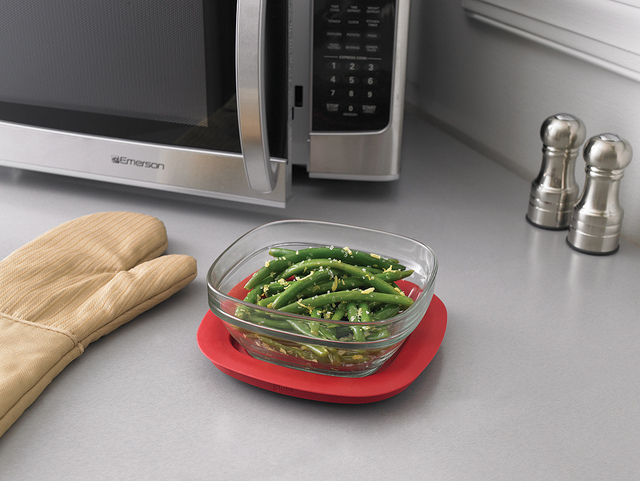Is the appliance next to the bowl a microwave or an oven, and can you describe it? The appliance next to the bowl appears to be a microwave, as indicated by the control panel with buttons and the characteristic microwave design. It's silver with a digital display and a large window on the door. How might one use the items seen in the image to prepare a meal? One could use the microwave to heat up the green beans in the bowl. The silicone pot holder beneath the bowl serves as a heat-resistant surface to place the hot dish after microwaving. 